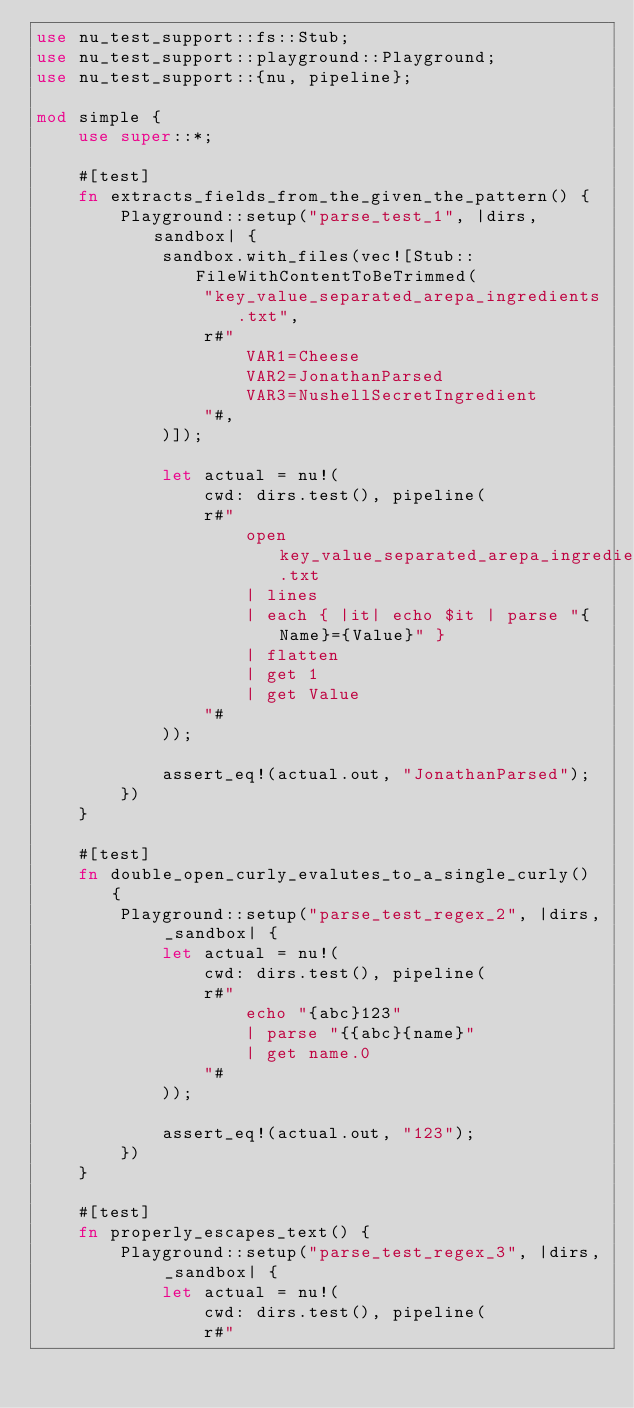Convert code to text. <code><loc_0><loc_0><loc_500><loc_500><_Rust_>use nu_test_support::fs::Stub;
use nu_test_support::playground::Playground;
use nu_test_support::{nu, pipeline};

mod simple {
    use super::*;

    #[test]
    fn extracts_fields_from_the_given_the_pattern() {
        Playground::setup("parse_test_1", |dirs, sandbox| {
            sandbox.with_files(vec![Stub::FileWithContentToBeTrimmed(
                "key_value_separated_arepa_ingredients.txt",
                r#"
                    VAR1=Cheese
                    VAR2=JonathanParsed
                    VAR3=NushellSecretIngredient
                "#,
            )]);

            let actual = nu!(
                cwd: dirs.test(), pipeline(
                r#"
                    open key_value_separated_arepa_ingredients.txt
                    | lines
                    | each { |it| echo $it | parse "{Name}={Value}" }
                    | flatten
                    | get 1
                    | get Value
                "#
            ));

            assert_eq!(actual.out, "JonathanParsed");
        })
    }

    #[test]
    fn double_open_curly_evalutes_to_a_single_curly() {
        Playground::setup("parse_test_regex_2", |dirs, _sandbox| {
            let actual = nu!(
                cwd: dirs.test(), pipeline(
                r#"
                    echo "{abc}123"
                    | parse "{{abc}{name}"
                    | get name.0
                "#
            ));

            assert_eq!(actual.out, "123");
        })
    }

    #[test]
    fn properly_escapes_text() {
        Playground::setup("parse_test_regex_3", |dirs, _sandbox| {
            let actual = nu!(
                cwd: dirs.test(), pipeline(
                r#"</code> 